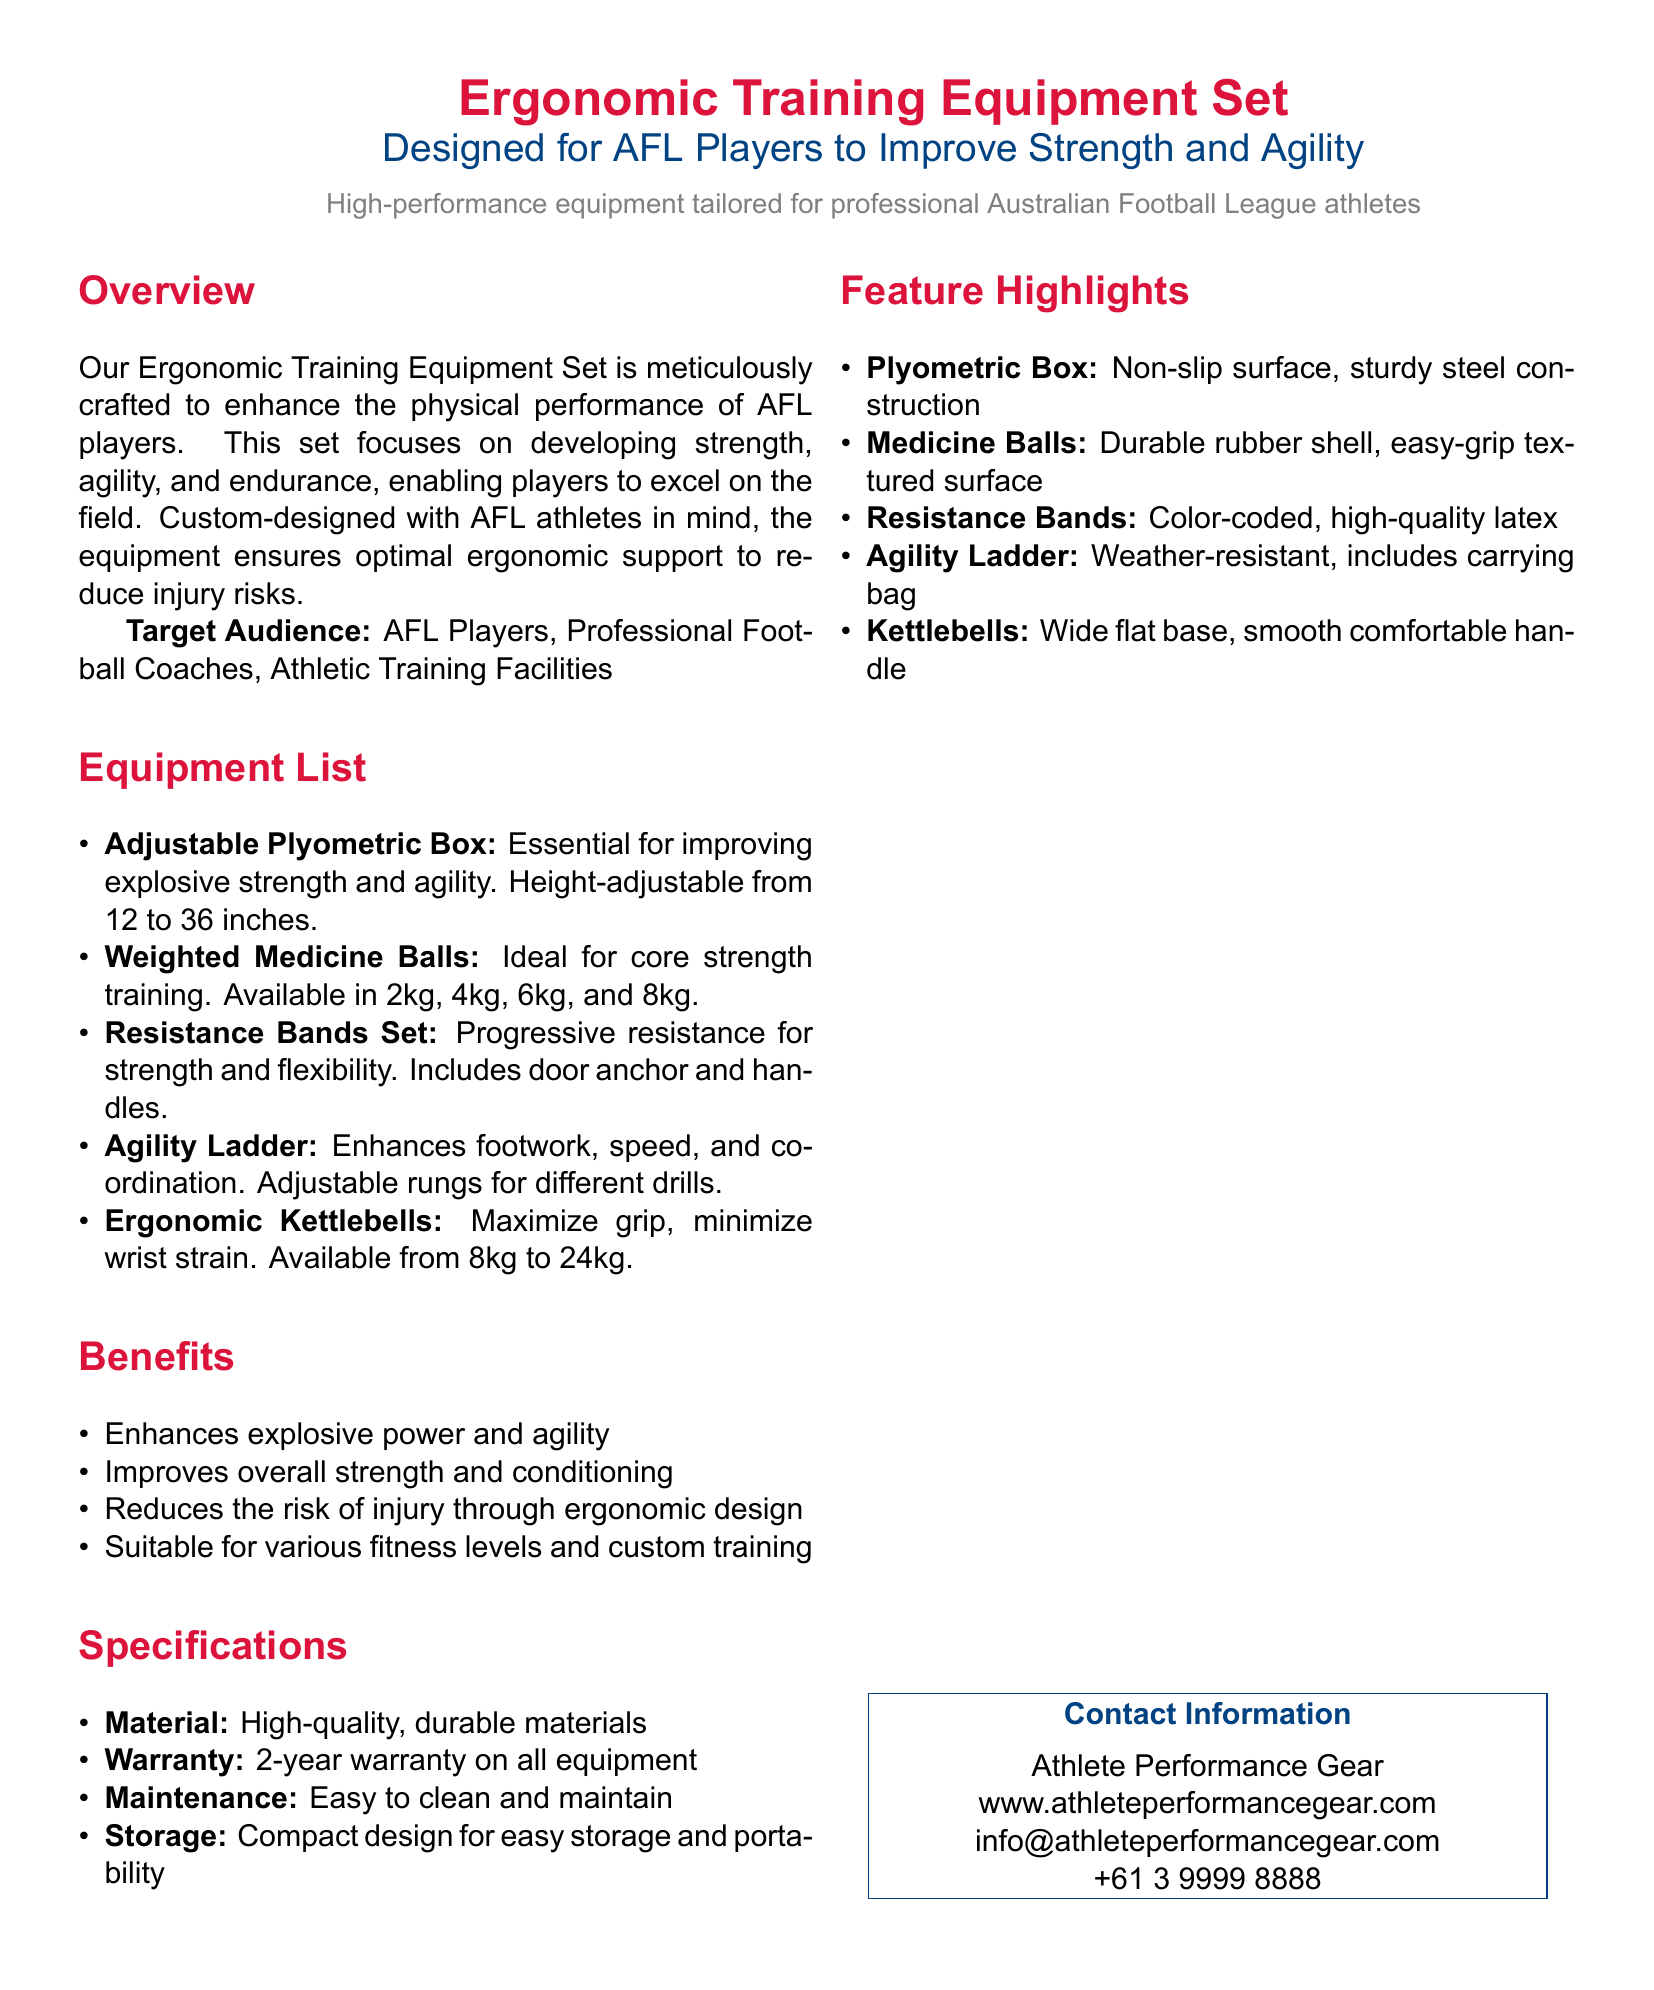What is the target audience for the equipment set? The target audience is specified in the document as AFL Players, Professional Football Coaches, and Athletic Training Facilities.
Answer: AFL Players, Professional Football Coaches, Athletic Training Facilities What is the range of heights for the Adjustable Plyometric Box? The height range for the Adjustable Plyometric Box is mentioned in the document, which states it is adjustable from 12 to 36 inches.
Answer: 12 to 36 inches What are the available weights for the Weighted Medicine Balls? The document lists the weights available for the Weighted Medicine Balls as 2kg, 4kg, 6kg, and 8kg.
Answer: 2kg, 4kg, 6kg, and 8kg How long is the warranty period for the equipment? The warranty period is explicitly stated in the document as a 2-year warranty on all equipment.
Answer: 2-year warranty What benefit does the ergonomic design provide? The document states that the ergonomic design reduces the risk of injury, which is a key benefit of the equipment set.
Answer: Reduces the risk of injury What type of material is the equipment made of? The material used for the equipment is described in the specifications as high-quality, durable materials.
Answer: High-quality, durable materials What is a feature of the Agility Ladder? The document mentions that the Agility Ladder includes a carrying bag, which is one of its features.
Answer: Includes carrying bag How many kettlebell weight options are provided? The document states that ergonomic kettlebells are available from 8kg to 24kg, indicating a range of weight options.
Answer: From 8kg to 24kg What is the contact email for Athlete Performance Gear? The contact information section lists the email address for inquiries as info@athleteperformancegear.com.
Answer: info@athleteperformancegear.com 